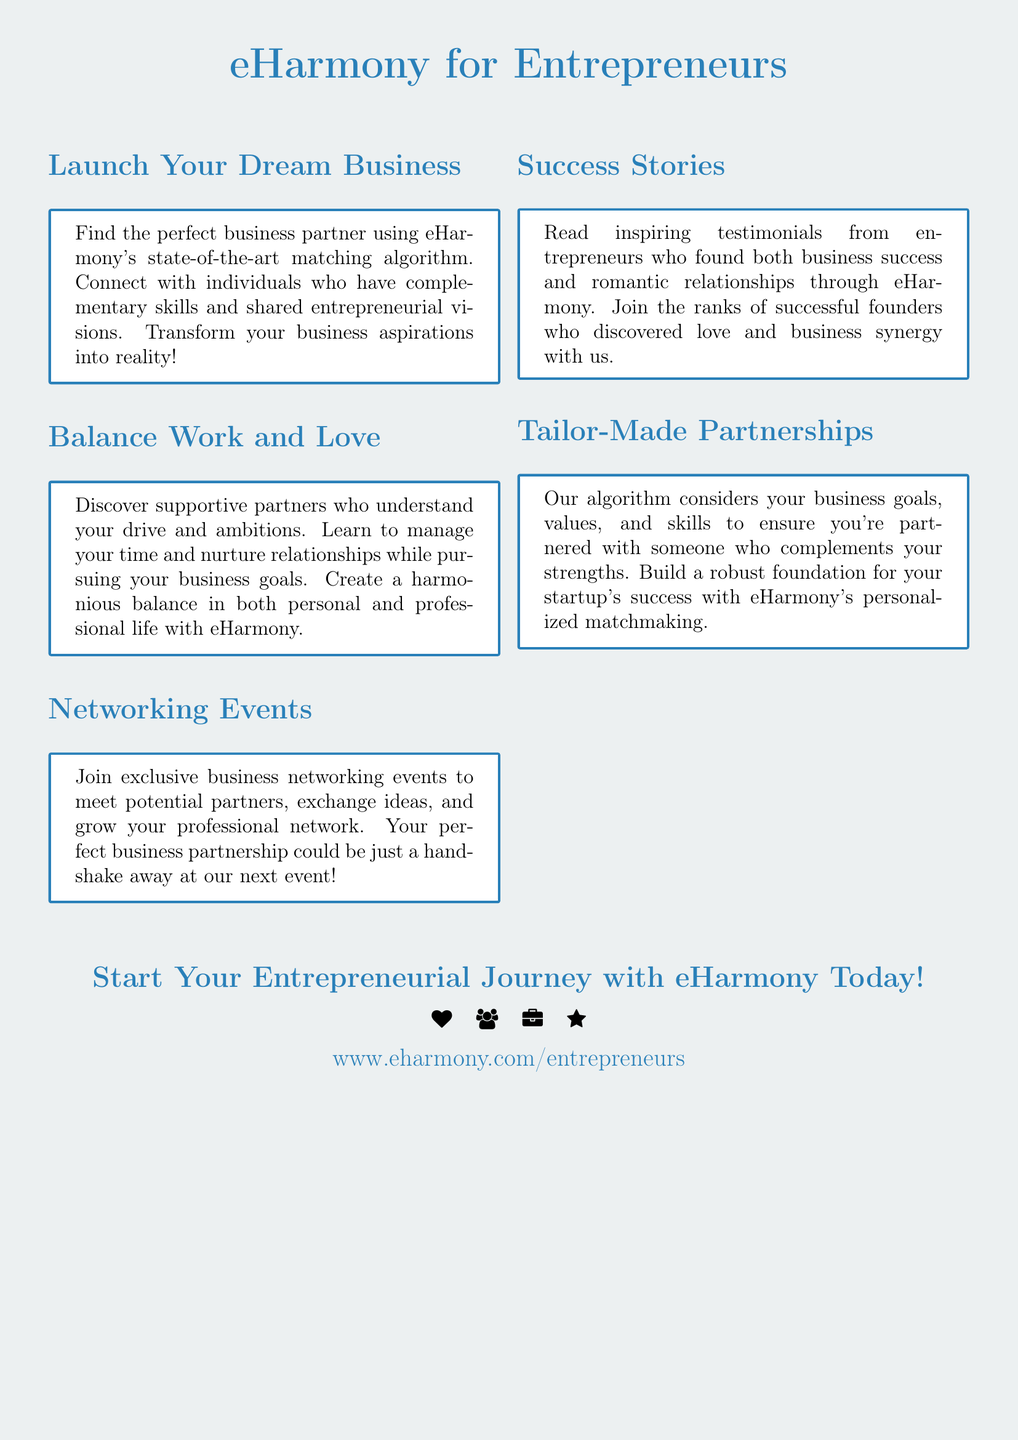What is eHarmony's matching algorithm designed to help with? The matching algorithm is designed to help find the perfect business partner with complementary skills and shared entrepreneurial visions.
Answer: Business partners What do networking events offer to entrepreneurs? The networking events offer opportunities to meet potential partners, exchange ideas, and grow professional networks.
Answer: Meet potential partners What can entrepreneurs achieve with eHarmony's personalized matchmaking? Entrepreneurs can build a robust foundation for their startup's success through personalized matchmaking.
Answer: Robust foundation What is one focus of the "Balance Work and Love" section? The focus is on managing time and nurturing relationships while pursuing business goals.
Answer: Managing time What type of stories are featured in the "Success Stories" section? The section features testimonials from entrepreneurs who found business success and romantic relationships through eHarmony.
Answer: Testimonials 